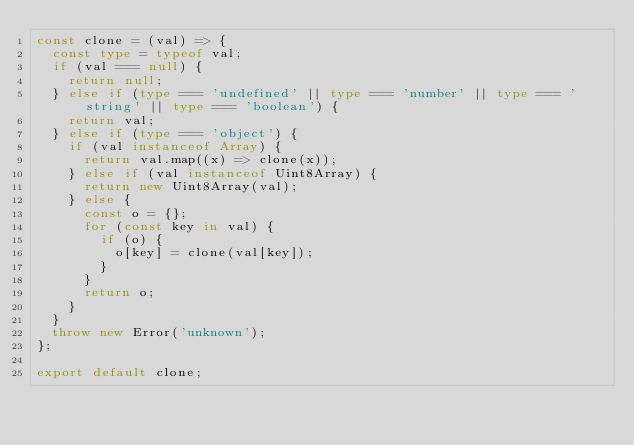Convert code to text. <code><loc_0><loc_0><loc_500><loc_500><_TypeScript_>const clone = (val) => {
  const type = typeof val;
  if (val === null) {
    return null;
  } else if (type === 'undefined' || type === 'number' || type === 'string' || type === 'boolean') {
    return val;
  } else if (type === 'object') {
    if (val instanceof Array) {
      return val.map((x) => clone(x));
    } else if (val instanceof Uint8Array) {
      return new Uint8Array(val);
    } else {
      const o = {};
      for (const key in val) {
        if (o) {
          o[key] = clone(val[key]);
        }
      }
      return o;
    }
  }
  throw new Error('unknown');
};

export default clone;
</code> 